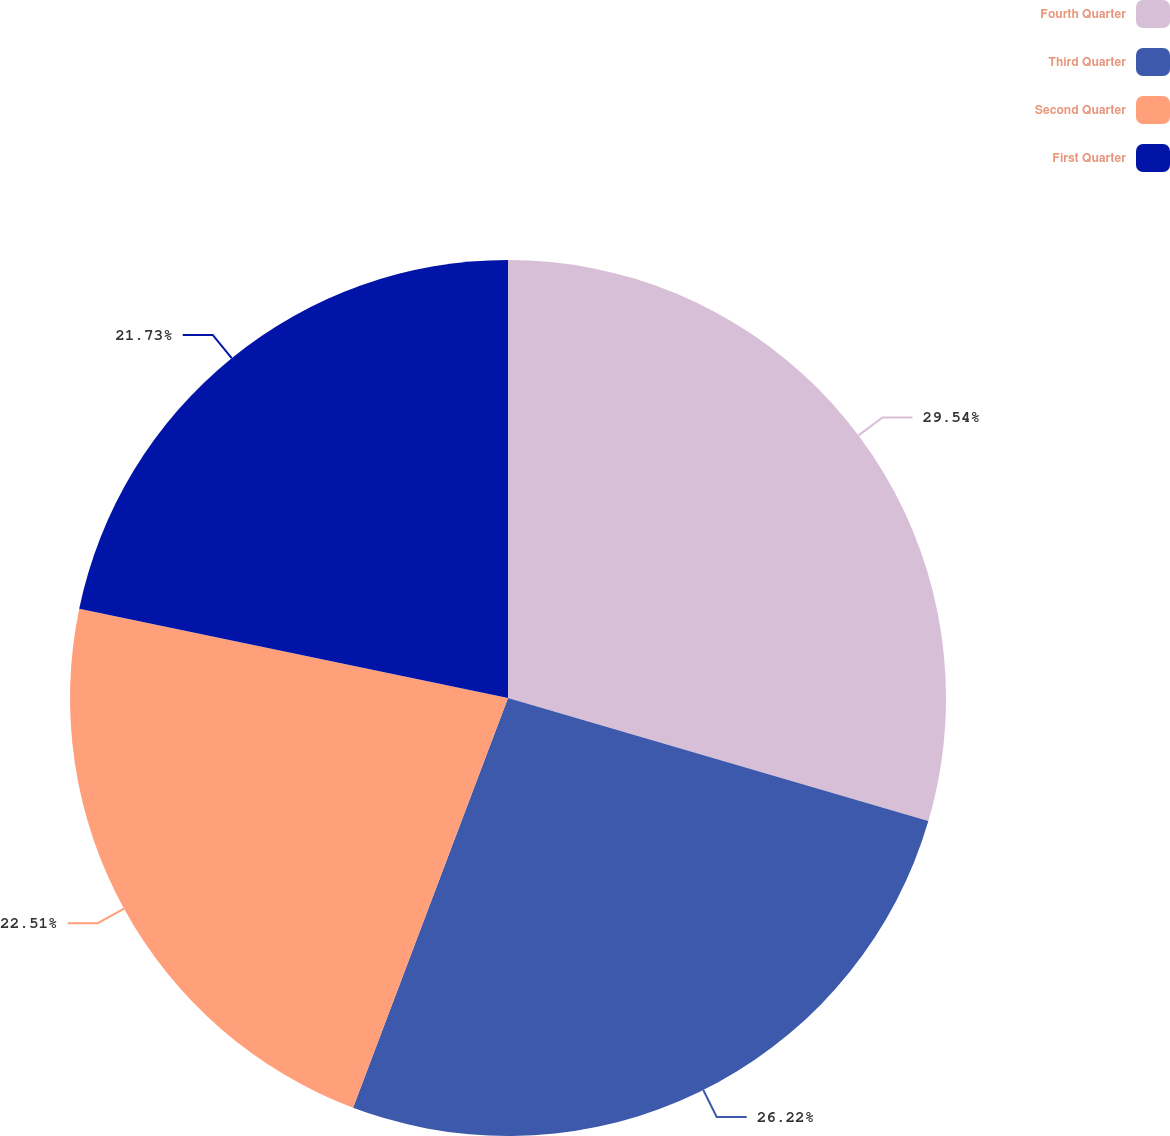Convert chart to OTSL. <chart><loc_0><loc_0><loc_500><loc_500><pie_chart><fcel>Fourth Quarter<fcel>Third Quarter<fcel>Second Quarter<fcel>First Quarter<nl><fcel>29.53%<fcel>26.22%<fcel>22.51%<fcel>21.73%<nl></chart> 